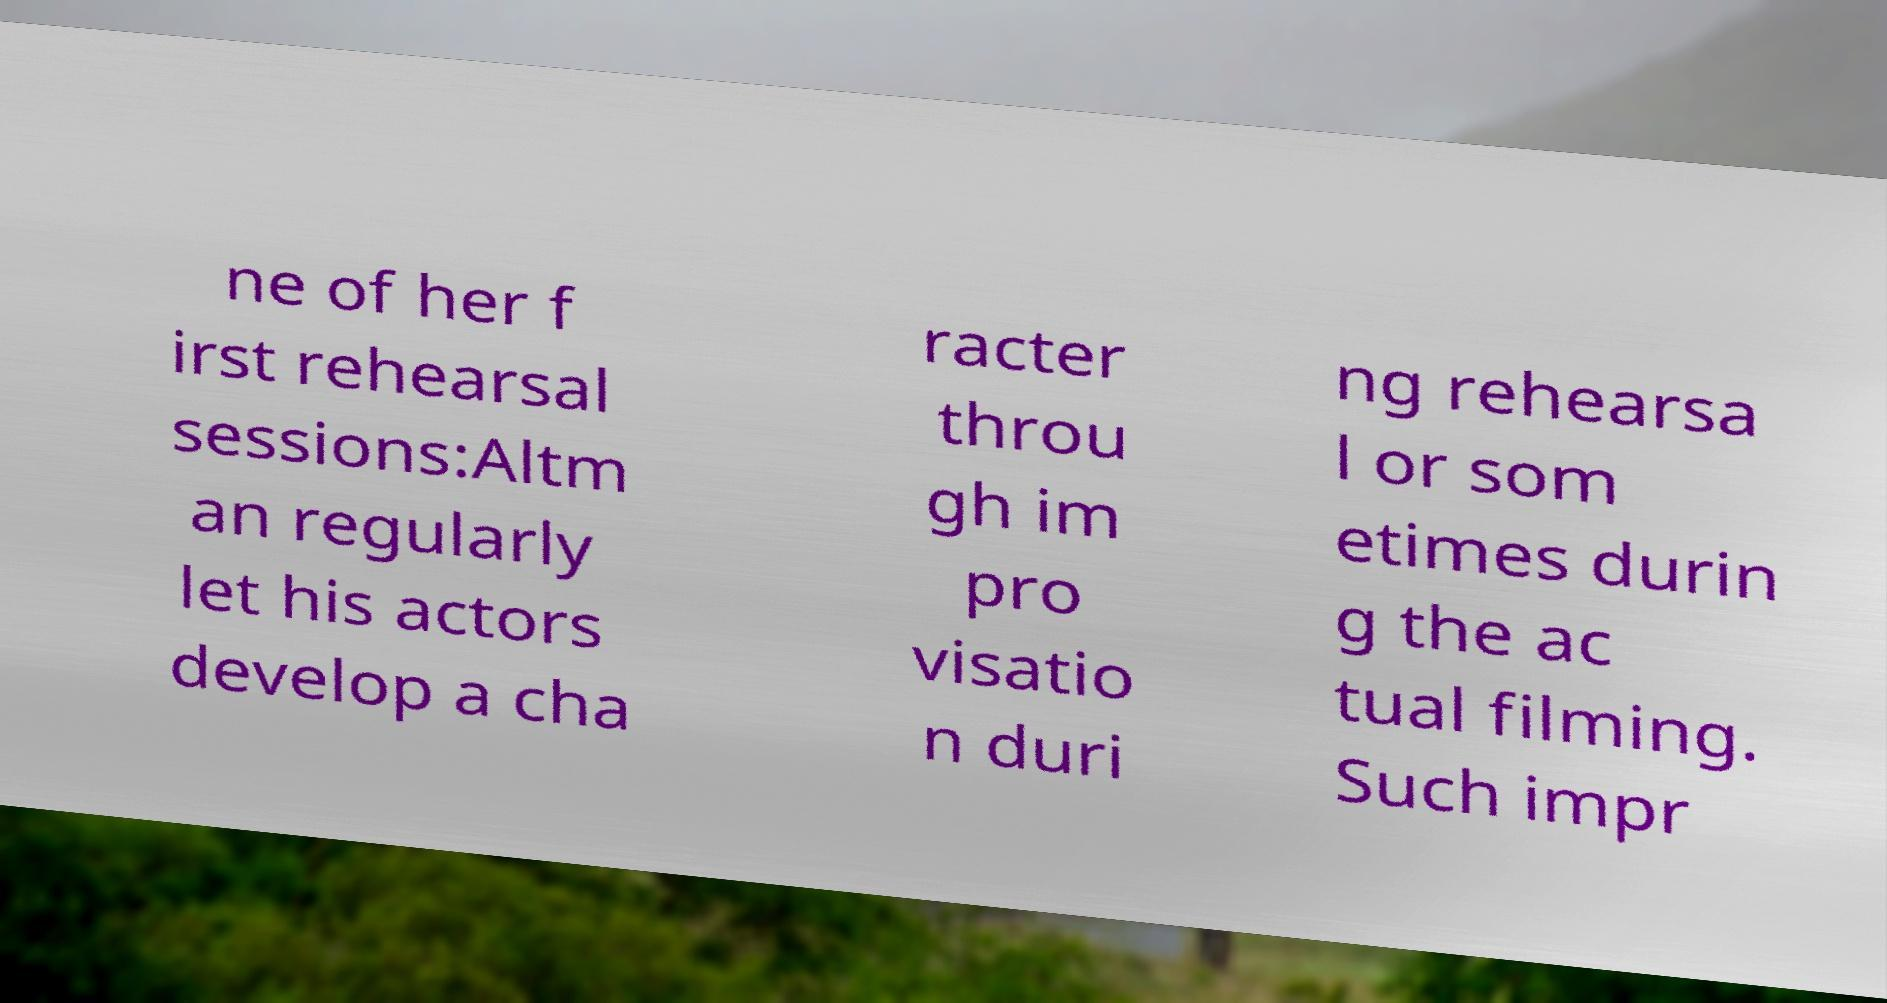Can you read and provide the text displayed in the image?This photo seems to have some interesting text. Can you extract and type it out for me? ne of her f irst rehearsal sessions:Altm an regularly let his actors develop a cha racter throu gh im pro visatio n duri ng rehearsa l or som etimes durin g the ac tual filming. Such impr 